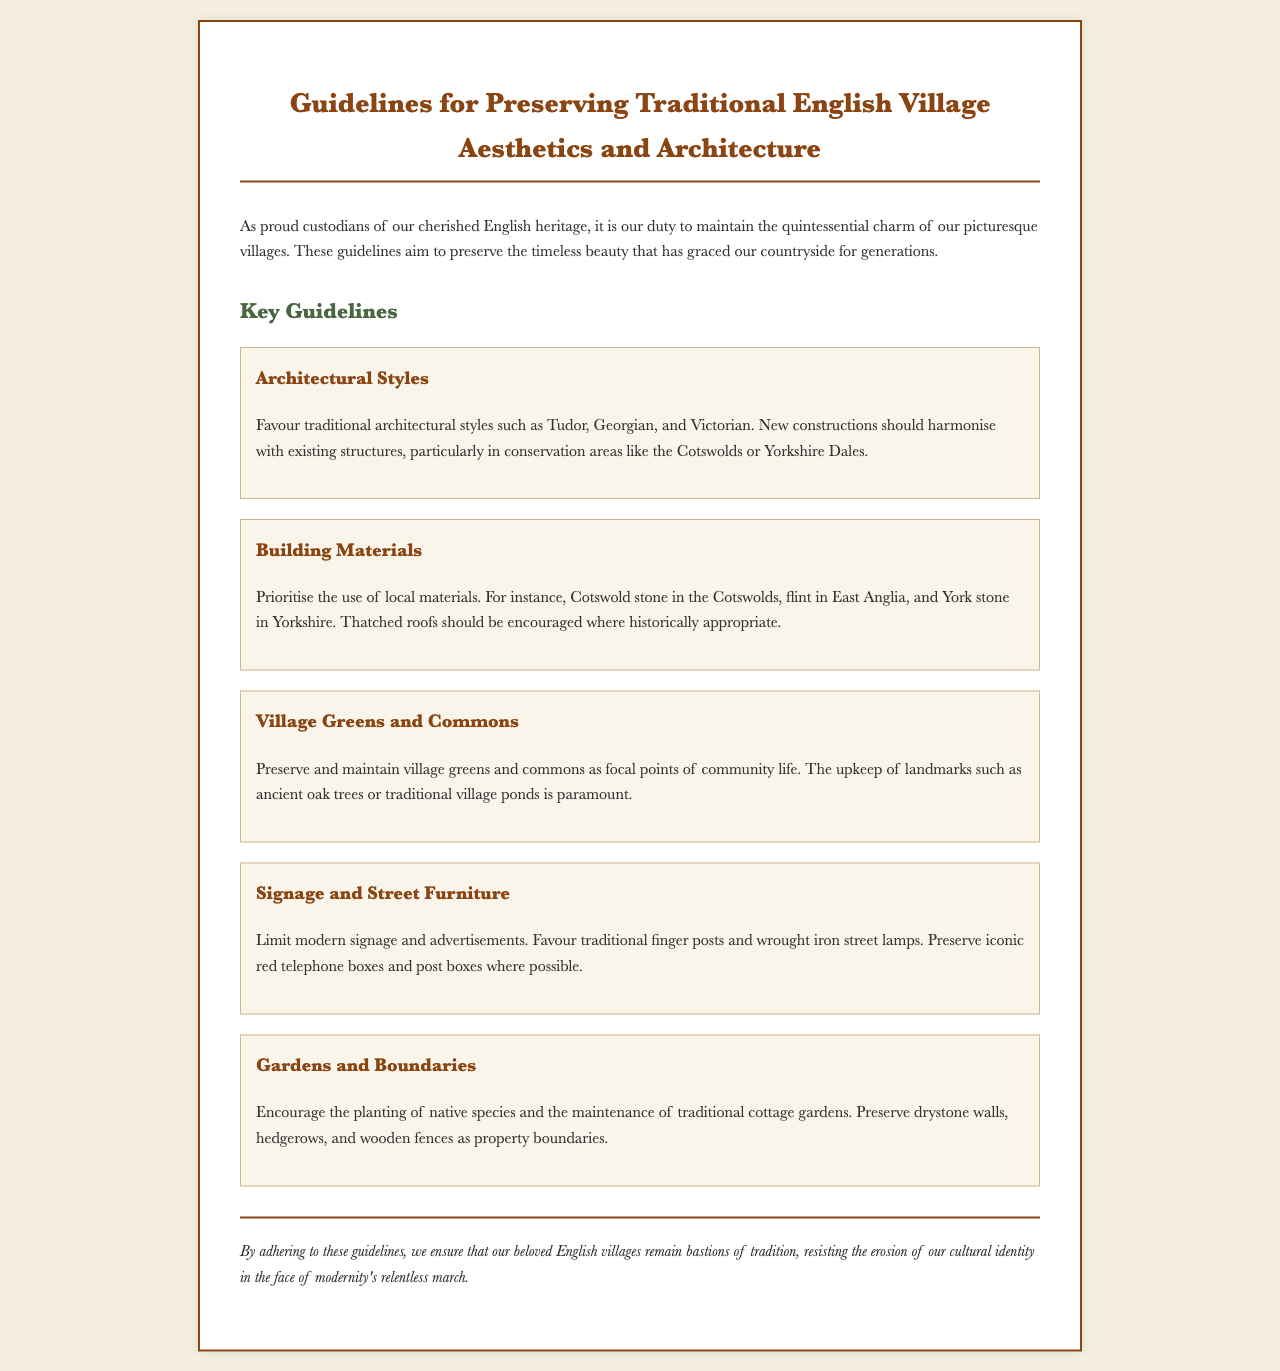what is the title of the document? The title is presented prominently at the top of the document.
Answer: Guidelines for Preserving Traditional English Village Aesthetics and Architecture which architectural styles are encouraged? The guidelines specifically mention the styles favored for new constructions.
Answer: Tudor, Georgian, and Victorian what materials should be prioritized for building? The document advises on the choice of materials that reflect local resources.
Answer: Local materials what should be preserved as focal points of community life? The guidelines state the importance of specific community features.
Answer: Village greens and commons how should modern signage be treated? The guidelines provide direction on the use of modern signage within the villages.
Answer: Limit modern signage and advertisements what type of gardens are encouraged? The guidelines indicate the type of gardens that align with traditional practices.
Answer: Traditional cottage gardens what is emphasized regarding village ponds? The document highlights the significance of maintaining specific community features.
Answer: Upkeep of traditional village ponds what should boundaries be preserved as? The guidelines mention certain structures that should be maintained as property boundaries.
Answer: Drystone walls, hedgerows, and wooden fences who are considered custodians of English heritage? The opening paragraph identifies a group responsible for preserving the aesthetic.
Answer: Proud custodians what is the conclusion of the guidelines? The conclusion summarizes the purpose of the guidelines.
Answer: Our beloved English villages remain bastions of tradition 